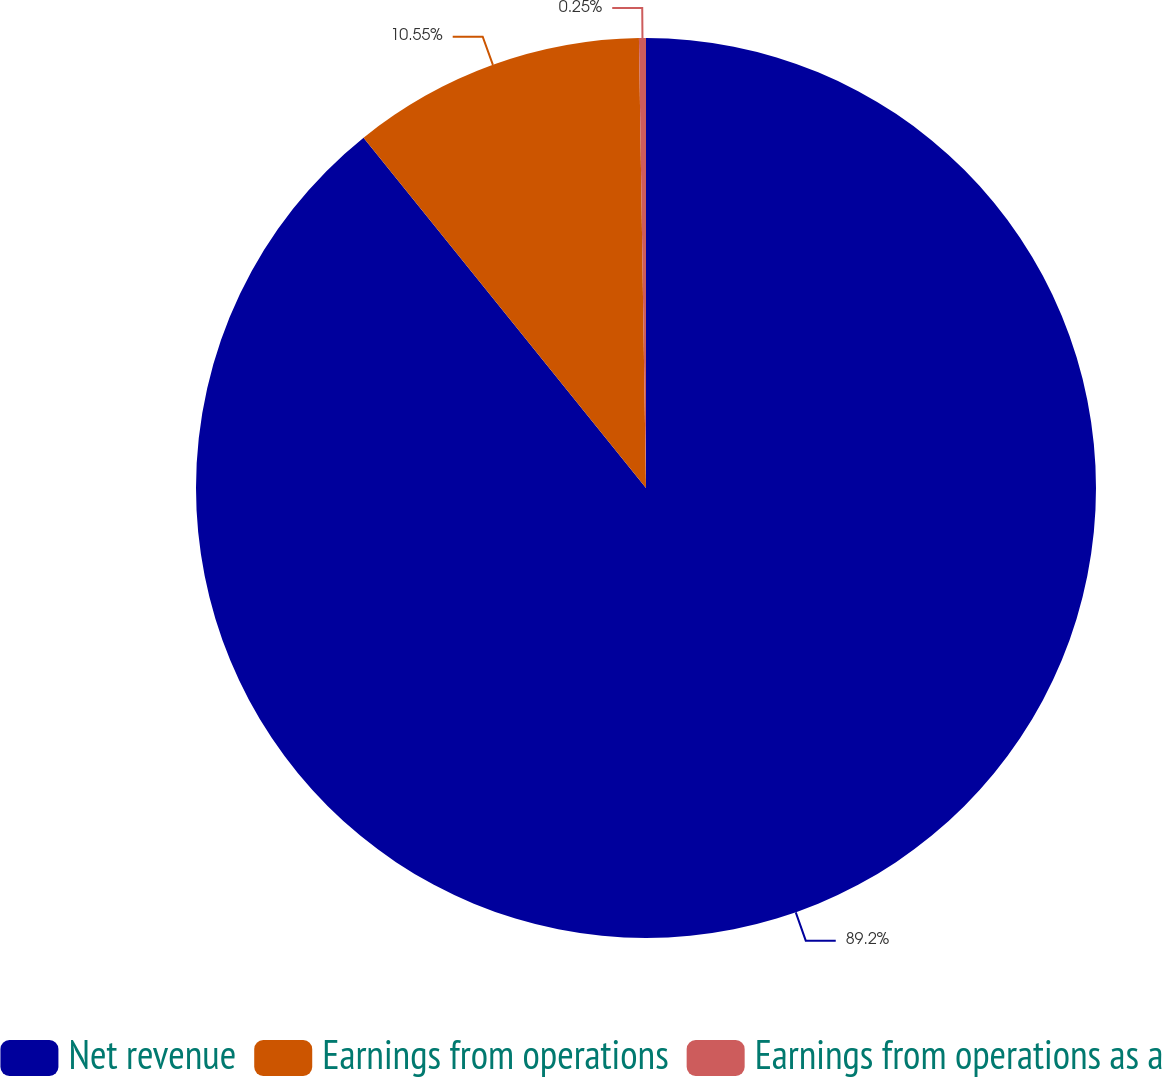<chart> <loc_0><loc_0><loc_500><loc_500><pie_chart><fcel>Net revenue<fcel>Earnings from operations<fcel>Earnings from operations as a<nl><fcel>89.2%<fcel>10.55%<fcel>0.25%<nl></chart> 